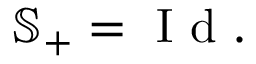<formula> <loc_0><loc_0><loc_500><loc_500>\mathbb { S } _ { + } = I d .</formula> 